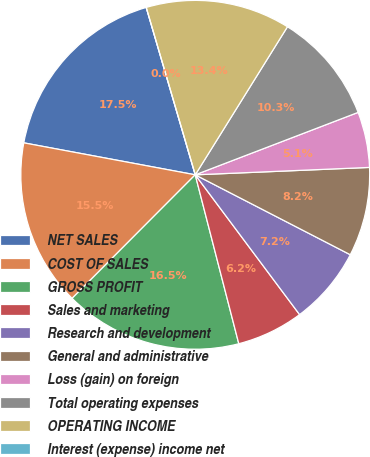Convert chart. <chart><loc_0><loc_0><loc_500><loc_500><pie_chart><fcel>NET SALES<fcel>COST OF SALES<fcel>GROSS PROFIT<fcel>Sales and marketing<fcel>Research and development<fcel>General and administrative<fcel>Loss (gain) on foreign<fcel>Total operating expenses<fcel>OPERATING INCOME<fcel>Interest (expense) income net<nl><fcel>17.53%<fcel>15.46%<fcel>16.49%<fcel>6.19%<fcel>7.22%<fcel>8.25%<fcel>5.15%<fcel>10.31%<fcel>13.4%<fcel>0.0%<nl></chart> 